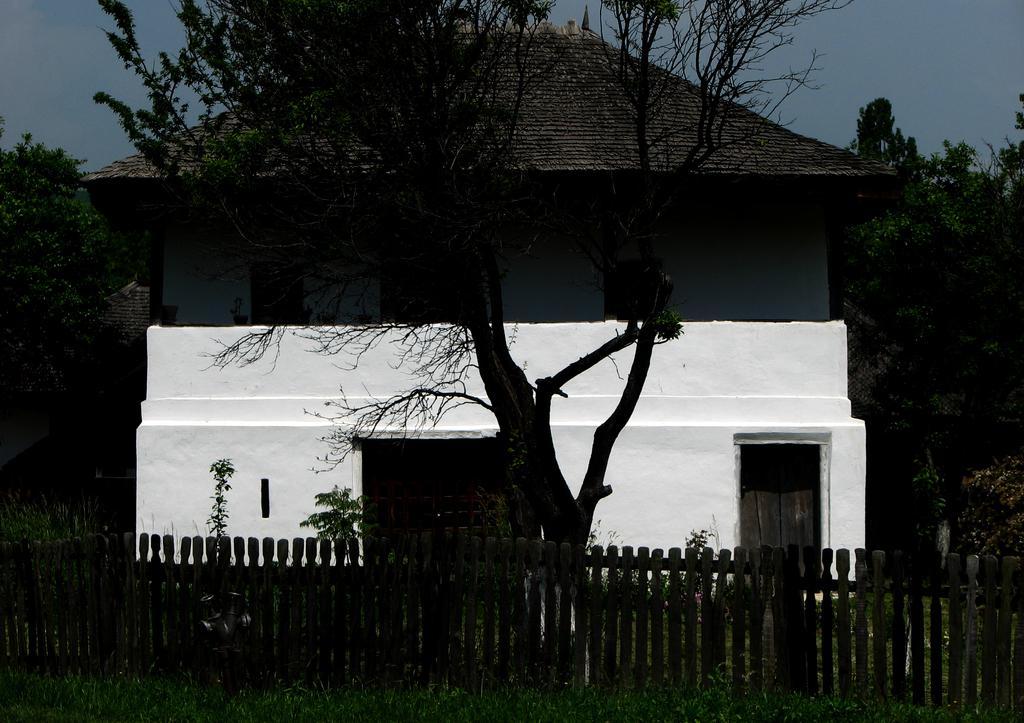In one or two sentences, can you explain what this image depicts? In this picture, there is a tree in the center. Behind it, there is a house which is in grey and white in color. On top of the house, there are roof tiles. At the bottom, there is a fence and a grass. In the background there are trees and sky. 